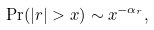Convert formula to latex. <formula><loc_0><loc_0><loc_500><loc_500>\Pr ( | r | > x ) \sim x ^ { - \alpha _ { r } } ,</formula> 